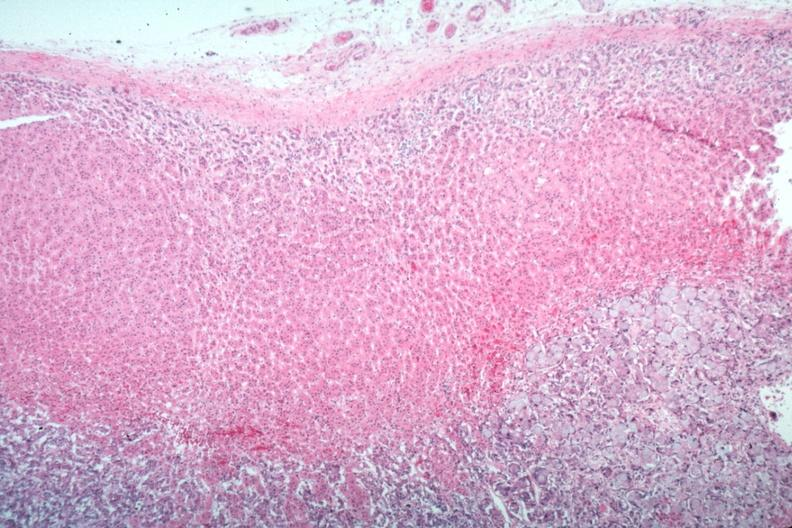does myocardial infarct show primary in stomach?
Answer the question using a single word or phrase. No 